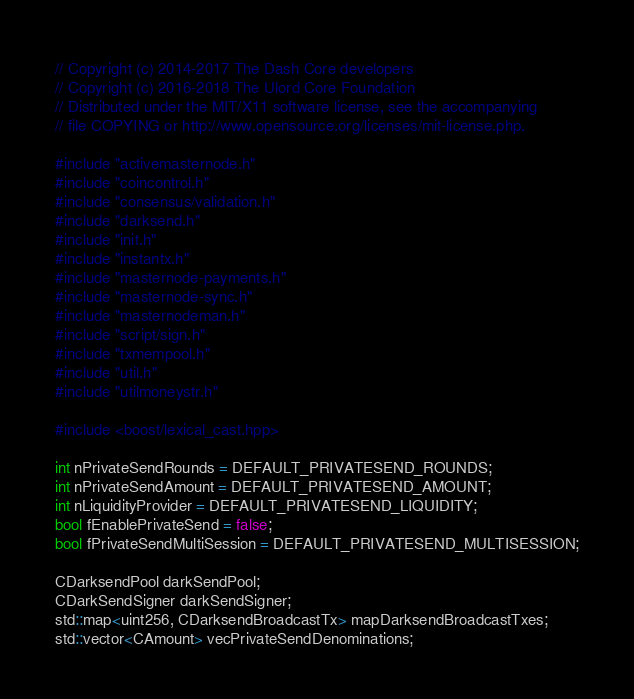Convert code to text. <code><loc_0><loc_0><loc_500><loc_500><_C++_>// Copyright (c) 2014-2017 The Dash Core developers
// Copyright (c) 2016-2018 The Ulord Core Foundation
// Distributed under the MIT/X11 software license, see the accompanying
// file COPYING or http://www.opensource.org/licenses/mit-license.php.

#include "activemasternode.h"
#include "coincontrol.h"
#include "consensus/validation.h"
#include "darksend.h"
#include "init.h"
#include "instantx.h"
#include "masternode-payments.h"
#include "masternode-sync.h"
#include "masternodeman.h"
#include "script/sign.h"
#include "txmempool.h"
#include "util.h"
#include "utilmoneystr.h"

#include <boost/lexical_cast.hpp>

int nPrivateSendRounds = DEFAULT_PRIVATESEND_ROUNDS;
int nPrivateSendAmount = DEFAULT_PRIVATESEND_AMOUNT;
int nLiquidityProvider = DEFAULT_PRIVATESEND_LIQUIDITY;
bool fEnablePrivateSend = false;
bool fPrivateSendMultiSession = DEFAULT_PRIVATESEND_MULTISESSION;

CDarksendPool darkSendPool;
CDarkSendSigner darkSendSigner;
std::map<uint256, CDarksendBroadcastTx> mapDarksendBroadcastTxes;
std::vector<CAmount> vecPrivateSendDenominations;
</code> 